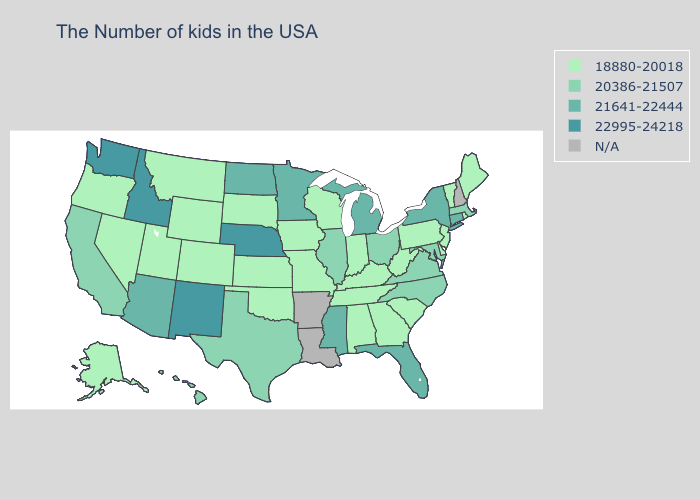Which states have the highest value in the USA?
Short answer required. Nebraska, New Mexico, Idaho, Washington. Name the states that have a value in the range 21641-22444?
Answer briefly. Connecticut, New York, Florida, Michigan, Mississippi, Minnesota, North Dakota, Arizona. Does the first symbol in the legend represent the smallest category?
Concise answer only. Yes. Does Maine have the lowest value in the USA?
Be succinct. Yes. Does California have the highest value in the West?
Write a very short answer. No. What is the value of Florida?
Answer briefly. 21641-22444. Does the map have missing data?
Keep it brief. Yes. What is the value of Rhode Island?
Keep it brief. 18880-20018. What is the lowest value in the MidWest?
Keep it brief. 18880-20018. What is the lowest value in the MidWest?
Be succinct. 18880-20018. Among the states that border Wisconsin , which have the lowest value?
Quick response, please. Iowa. Which states have the lowest value in the USA?
Keep it brief. Maine, Rhode Island, Vermont, New Jersey, Delaware, Pennsylvania, South Carolina, West Virginia, Georgia, Kentucky, Indiana, Alabama, Tennessee, Wisconsin, Missouri, Iowa, Kansas, Oklahoma, South Dakota, Wyoming, Colorado, Utah, Montana, Nevada, Oregon, Alaska. Name the states that have a value in the range 20386-21507?
Quick response, please. Massachusetts, Maryland, Virginia, North Carolina, Ohio, Illinois, Texas, California, Hawaii. Which states have the lowest value in the West?
Answer briefly. Wyoming, Colorado, Utah, Montana, Nevada, Oregon, Alaska. Does Kansas have the lowest value in the USA?
Write a very short answer. Yes. 